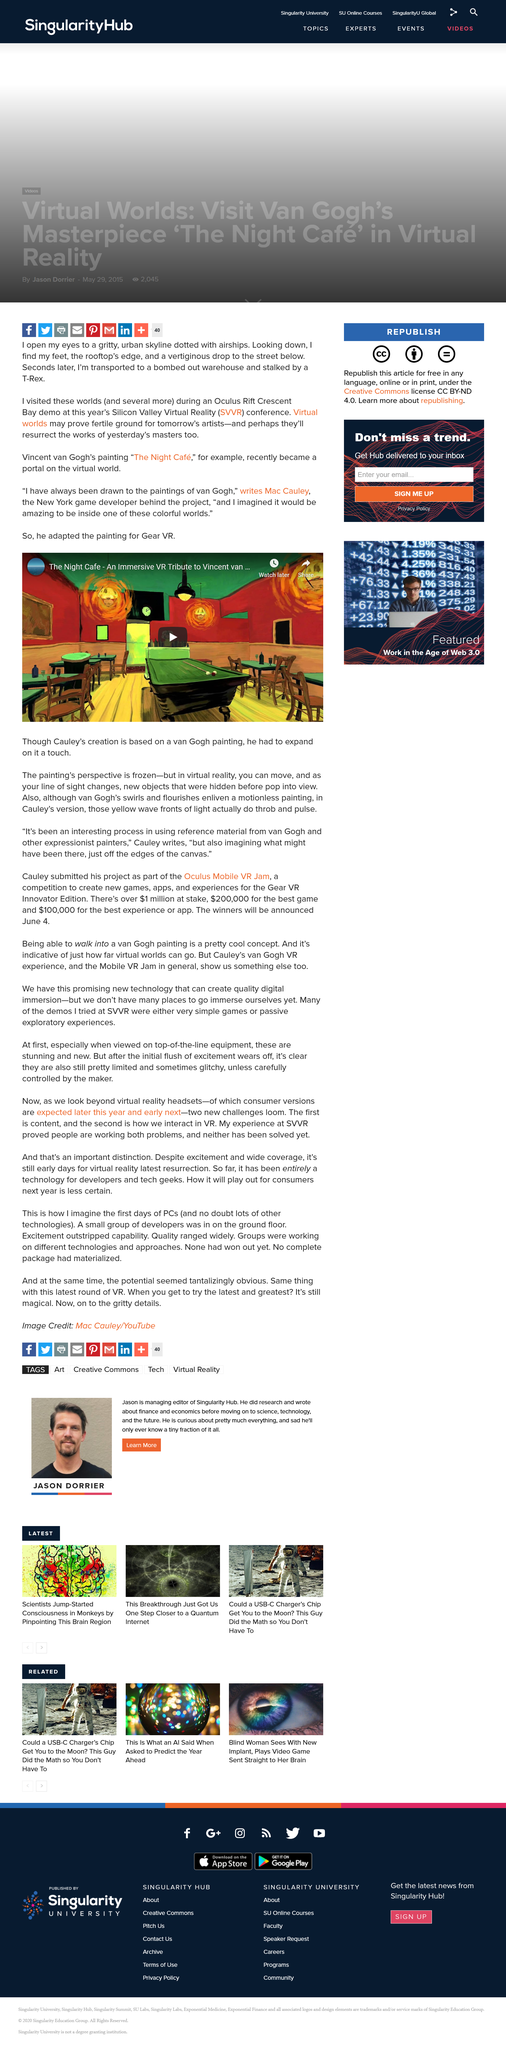Indicate a few pertinent items in this graphic. McCauley chose one of Van Gogh's paintings because he has always been drawn to its unique and vibrant style, and he desired to immerse himself in the radiant world depicted within the canvas. Vincent Van Gogh's "The Night Café" became a portal to the virtual world, allowing viewers to step inside the famous painting and explore its enigmatic depths. The Oculus Rift Crescent Bay demo was held at the Silicon Valley Virtual Reality Conference. 